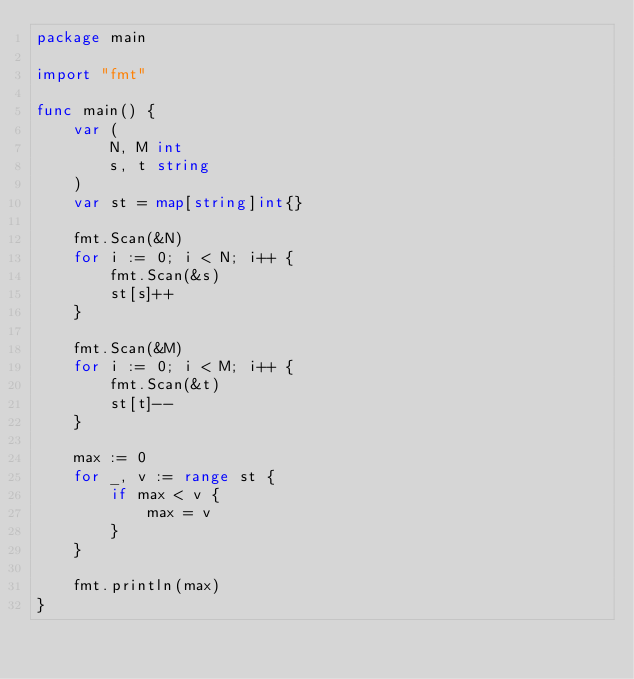<code> <loc_0><loc_0><loc_500><loc_500><_Go_>package main

import "fmt"

func main() {
	var (
		N, M int
		s, t string
	)
	var st = map[string]int{}

	fmt.Scan(&N)
	for i := 0; i < N; i++ {
		fmt.Scan(&s)
		st[s]++
	}

	fmt.Scan(&M)
	for i := 0; i < M; i++ {
		fmt.Scan(&t)
		st[t]--
	}

	max := 0
	for _, v := range st {
		if max < v {
			max = v
		}
	}

	fmt.println(max)
}
</code> 